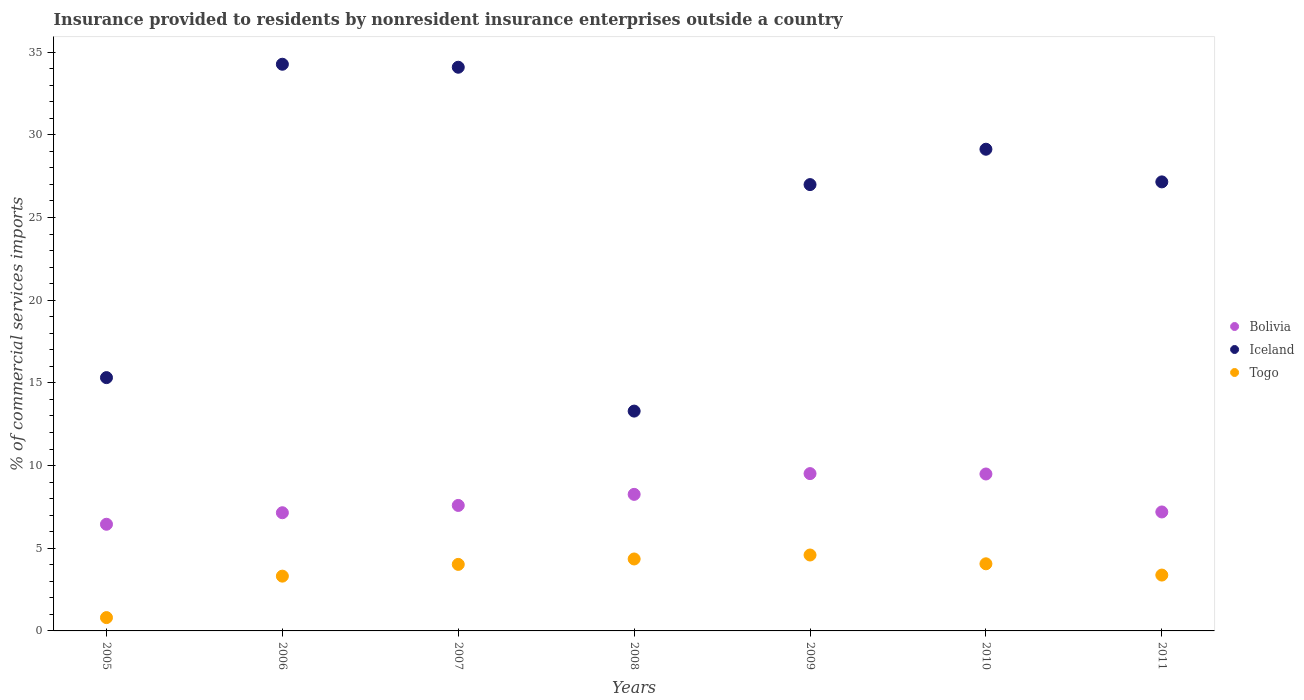How many different coloured dotlines are there?
Provide a succinct answer. 3. What is the Insurance provided to residents in Bolivia in 2010?
Your answer should be compact. 9.49. Across all years, what is the maximum Insurance provided to residents in Iceland?
Keep it short and to the point. 34.27. Across all years, what is the minimum Insurance provided to residents in Iceland?
Provide a short and direct response. 13.29. In which year was the Insurance provided to residents in Togo maximum?
Your answer should be compact. 2009. What is the total Insurance provided to residents in Iceland in the graph?
Your answer should be compact. 180.25. What is the difference between the Insurance provided to residents in Bolivia in 2005 and that in 2010?
Ensure brevity in your answer.  -3.04. What is the difference between the Insurance provided to residents in Bolivia in 2008 and the Insurance provided to residents in Togo in 2007?
Offer a very short reply. 4.23. What is the average Insurance provided to residents in Togo per year?
Your answer should be very brief. 3.5. In the year 2008, what is the difference between the Insurance provided to residents in Togo and Insurance provided to residents in Iceland?
Ensure brevity in your answer.  -8.94. In how many years, is the Insurance provided to residents in Bolivia greater than 10 %?
Give a very brief answer. 0. What is the ratio of the Insurance provided to residents in Bolivia in 2009 to that in 2011?
Your response must be concise. 1.32. Is the Insurance provided to residents in Togo in 2005 less than that in 2011?
Your answer should be compact. Yes. What is the difference between the highest and the second highest Insurance provided to residents in Iceland?
Provide a succinct answer. 0.18. What is the difference between the highest and the lowest Insurance provided to residents in Iceland?
Provide a short and direct response. 20.98. Is the Insurance provided to residents in Togo strictly less than the Insurance provided to residents in Iceland over the years?
Provide a short and direct response. Yes. How many dotlines are there?
Offer a terse response. 3. What is the difference between two consecutive major ticks on the Y-axis?
Your answer should be compact. 5. Does the graph contain any zero values?
Your answer should be compact. No. Does the graph contain grids?
Ensure brevity in your answer.  No. Where does the legend appear in the graph?
Provide a succinct answer. Center right. What is the title of the graph?
Your response must be concise. Insurance provided to residents by nonresident insurance enterprises outside a country. What is the label or title of the Y-axis?
Offer a very short reply. % of commercial services imports. What is the % of commercial services imports in Bolivia in 2005?
Ensure brevity in your answer.  6.45. What is the % of commercial services imports of Iceland in 2005?
Ensure brevity in your answer.  15.32. What is the % of commercial services imports in Togo in 2005?
Make the answer very short. 0.81. What is the % of commercial services imports in Bolivia in 2006?
Your answer should be compact. 7.15. What is the % of commercial services imports in Iceland in 2006?
Make the answer very short. 34.27. What is the % of commercial services imports in Togo in 2006?
Your response must be concise. 3.31. What is the % of commercial services imports in Bolivia in 2007?
Your response must be concise. 7.59. What is the % of commercial services imports of Iceland in 2007?
Offer a terse response. 34.09. What is the % of commercial services imports in Togo in 2007?
Your answer should be very brief. 4.02. What is the % of commercial services imports of Bolivia in 2008?
Give a very brief answer. 8.26. What is the % of commercial services imports of Iceland in 2008?
Make the answer very short. 13.29. What is the % of commercial services imports in Togo in 2008?
Offer a terse response. 4.35. What is the % of commercial services imports in Bolivia in 2009?
Your answer should be compact. 9.51. What is the % of commercial services imports of Iceland in 2009?
Offer a very short reply. 26.99. What is the % of commercial services imports in Togo in 2009?
Offer a terse response. 4.59. What is the % of commercial services imports in Bolivia in 2010?
Ensure brevity in your answer.  9.49. What is the % of commercial services imports of Iceland in 2010?
Provide a short and direct response. 29.13. What is the % of commercial services imports in Togo in 2010?
Your response must be concise. 4.06. What is the % of commercial services imports of Bolivia in 2011?
Keep it short and to the point. 7.19. What is the % of commercial services imports of Iceland in 2011?
Offer a very short reply. 27.16. What is the % of commercial services imports of Togo in 2011?
Offer a very short reply. 3.38. Across all years, what is the maximum % of commercial services imports of Bolivia?
Offer a very short reply. 9.51. Across all years, what is the maximum % of commercial services imports of Iceland?
Give a very brief answer. 34.27. Across all years, what is the maximum % of commercial services imports in Togo?
Provide a short and direct response. 4.59. Across all years, what is the minimum % of commercial services imports of Bolivia?
Make the answer very short. 6.45. Across all years, what is the minimum % of commercial services imports of Iceland?
Offer a terse response. 13.29. Across all years, what is the minimum % of commercial services imports in Togo?
Give a very brief answer. 0.81. What is the total % of commercial services imports of Bolivia in the graph?
Your answer should be compact. 55.64. What is the total % of commercial services imports of Iceland in the graph?
Offer a terse response. 180.25. What is the total % of commercial services imports of Togo in the graph?
Provide a succinct answer. 24.52. What is the difference between the % of commercial services imports in Bolivia in 2005 and that in 2006?
Your answer should be compact. -0.7. What is the difference between the % of commercial services imports of Iceland in 2005 and that in 2006?
Offer a terse response. -18.95. What is the difference between the % of commercial services imports in Togo in 2005 and that in 2006?
Give a very brief answer. -2.51. What is the difference between the % of commercial services imports in Bolivia in 2005 and that in 2007?
Ensure brevity in your answer.  -1.14. What is the difference between the % of commercial services imports in Iceland in 2005 and that in 2007?
Provide a succinct answer. -18.77. What is the difference between the % of commercial services imports in Togo in 2005 and that in 2007?
Provide a succinct answer. -3.22. What is the difference between the % of commercial services imports in Bolivia in 2005 and that in 2008?
Offer a terse response. -1.81. What is the difference between the % of commercial services imports of Iceland in 2005 and that in 2008?
Offer a very short reply. 2.03. What is the difference between the % of commercial services imports of Togo in 2005 and that in 2008?
Your answer should be compact. -3.55. What is the difference between the % of commercial services imports of Bolivia in 2005 and that in 2009?
Keep it short and to the point. -3.06. What is the difference between the % of commercial services imports of Iceland in 2005 and that in 2009?
Ensure brevity in your answer.  -11.67. What is the difference between the % of commercial services imports in Togo in 2005 and that in 2009?
Your response must be concise. -3.79. What is the difference between the % of commercial services imports in Bolivia in 2005 and that in 2010?
Give a very brief answer. -3.04. What is the difference between the % of commercial services imports in Iceland in 2005 and that in 2010?
Provide a succinct answer. -13.81. What is the difference between the % of commercial services imports of Togo in 2005 and that in 2010?
Your answer should be compact. -3.25. What is the difference between the % of commercial services imports in Bolivia in 2005 and that in 2011?
Provide a succinct answer. -0.74. What is the difference between the % of commercial services imports of Iceland in 2005 and that in 2011?
Give a very brief answer. -11.84. What is the difference between the % of commercial services imports of Togo in 2005 and that in 2011?
Make the answer very short. -2.57. What is the difference between the % of commercial services imports of Bolivia in 2006 and that in 2007?
Give a very brief answer. -0.44. What is the difference between the % of commercial services imports of Iceland in 2006 and that in 2007?
Offer a terse response. 0.18. What is the difference between the % of commercial services imports in Togo in 2006 and that in 2007?
Offer a very short reply. -0.71. What is the difference between the % of commercial services imports in Bolivia in 2006 and that in 2008?
Provide a short and direct response. -1.11. What is the difference between the % of commercial services imports in Iceland in 2006 and that in 2008?
Your answer should be compact. 20.98. What is the difference between the % of commercial services imports of Togo in 2006 and that in 2008?
Keep it short and to the point. -1.04. What is the difference between the % of commercial services imports in Bolivia in 2006 and that in 2009?
Keep it short and to the point. -2.37. What is the difference between the % of commercial services imports of Iceland in 2006 and that in 2009?
Provide a succinct answer. 7.28. What is the difference between the % of commercial services imports of Togo in 2006 and that in 2009?
Your answer should be very brief. -1.28. What is the difference between the % of commercial services imports in Bolivia in 2006 and that in 2010?
Provide a short and direct response. -2.34. What is the difference between the % of commercial services imports of Iceland in 2006 and that in 2010?
Give a very brief answer. 5.14. What is the difference between the % of commercial services imports in Togo in 2006 and that in 2010?
Your answer should be very brief. -0.75. What is the difference between the % of commercial services imports of Bolivia in 2006 and that in 2011?
Make the answer very short. -0.05. What is the difference between the % of commercial services imports of Iceland in 2006 and that in 2011?
Provide a succinct answer. 7.11. What is the difference between the % of commercial services imports of Togo in 2006 and that in 2011?
Provide a short and direct response. -0.06. What is the difference between the % of commercial services imports in Bolivia in 2007 and that in 2008?
Your answer should be very brief. -0.67. What is the difference between the % of commercial services imports of Iceland in 2007 and that in 2008?
Your response must be concise. 20.8. What is the difference between the % of commercial services imports of Togo in 2007 and that in 2008?
Provide a short and direct response. -0.33. What is the difference between the % of commercial services imports of Bolivia in 2007 and that in 2009?
Keep it short and to the point. -1.92. What is the difference between the % of commercial services imports of Iceland in 2007 and that in 2009?
Make the answer very short. 7.1. What is the difference between the % of commercial services imports of Togo in 2007 and that in 2009?
Offer a terse response. -0.57. What is the difference between the % of commercial services imports in Bolivia in 2007 and that in 2010?
Offer a terse response. -1.9. What is the difference between the % of commercial services imports of Iceland in 2007 and that in 2010?
Make the answer very short. 4.96. What is the difference between the % of commercial services imports of Togo in 2007 and that in 2010?
Offer a very short reply. -0.04. What is the difference between the % of commercial services imports of Bolivia in 2007 and that in 2011?
Provide a short and direct response. 0.39. What is the difference between the % of commercial services imports in Iceland in 2007 and that in 2011?
Give a very brief answer. 6.93. What is the difference between the % of commercial services imports of Togo in 2007 and that in 2011?
Your answer should be compact. 0.65. What is the difference between the % of commercial services imports in Bolivia in 2008 and that in 2009?
Offer a terse response. -1.26. What is the difference between the % of commercial services imports of Iceland in 2008 and that in 2009?
Ensure brevity in your answer.  -13.7. What is the difference between the % of commercial services imports of Togo in 2008 and that in 2009?
Make the answer very short. -0.24. What is the difference between the % of commercial services imports in Bolivia in 2008 and that in 2010?
Provide a succinct answer. -1.23. What is the difference between the % of commercial services imports in Iceland in 2008 and that in 2010?
Give a very brief answer. -15.84. What is the difference between the % of commercial services imports in Togo in 2008 and that in 2010?
Your response must be concise. 0.29. What is the difference between the % of commercial services imports in Bolivia in 2008 and that in 2011?
Your response must be concise. 1.06. What is the difference between the % of commercial services imports of Iceland in 2008 and that in 2011?
Make the answer very short. -13.86. What is the difference between the % of commercial services imports in Togo in 2008 and that in 2011?
Provide a succinct answer. 0.97. What is the difference between the % of commercial services imports in Bolivia in 2009 and that in 2010?
Keep it short and to the point. 0.02. What is the difference between the % of commercial services imports in Iceland in 2009 and that in 2010?
Give a very brief answer. -2.14. What is the difference between the % of commercial services imports in Togo in 2009 and that in 2010?
Provide a short and direct response. 0.53. What is the difference between the % of commercial services imports in Bolivia in 2009 and that in 2011?
Give a very brief answer. 2.32. What is the difference between the % of commercial services imports in Iceland in 2009 and that in 2011?
Keep it short and to the point. -0.16. What is the difference between the % of commercial services imports of Togo in 2009 and that in 2011?
Your response must be concise. 1.21. What is the difference between the % of commercial services imports of Bolivia in 2010 and that in 2011?
Your answer should be compact. 2.3. What is the difference between the % of commercial services imports in Iceland in 2010 and that in 2011?
Ensure brevity in your answer.  1.98. What is the difference between the % of commercial services imports in Togo in 2010 and that in 2011?
Provide a succinct answer. 0.68. What is the difference between the % of commercial services imports in Bolivia in 2005 and the % of commercial services imports in Iceland in 2006?
Offer a terse response. -27.82. What is the difference between the % of commercial services imports in Bolivia in 2005 and the % of commercial services imports in Togo in 2006?
Give a very brief answer. 3.14. What is the difference between the % of commercial services imports in Iceland in 2005 and the % of commercial services imports in Togo in 2006?
Provide a succinct answer. 12.01. What is the difference between the % of commercial services imports in Bolivia in 2005 and the % of commercial services imports in Iceland in 2007?
Your answer should be compact. -27.64. What is the difference between the % of commercial services imports of Bolivia in 2005 and the % of commercial services imports of Togo in 2007?
Ensure brevity in your answer.  2.43. What is the difference between the % of commercial services imports in Iceland in 2005 and the % of commercial services imports in Togo in 2007?
Give a very brief answer. 11.3. What is the difference between the % of commercial services imports of Bolivia in 2005 and the % of commercial services imports of Iceland in 2008?
Your response must be concise. -6.84. What is the difference between the % of commercial services imports of Bolivia in 2005 and the % of commercial services imports of Togo in 2008?
Make the answer very short. 2.1. What is the difference between the % of commercial services imports of Iceland in 2005 and the % of commercial services imports of Togo in 2008?
Your answer should be compact. 10.97. What is the difference between the % of commercial services imports in Bolivia in 2005 and the % of commercial services imports in Iceland in 2009?
Provide a succinct answer. -20.54. What is the difference between the % of commercial services imports of Bolivia in 2005 and the % of commercial services imports of Togo in 2009?
Ensure brevity in your answer.  1.86. What is the difference between the % of commercial services imports of Iceland in 2005 and the % of commercial services imports of Togo in 2009?
Make the answer very short. 10.73. What is the difference between the % of commercial services imports of Bolivia in 2005 and the % of commercial services imports of Iceland in 2010?
Your answer should be very brief. -22.68. What is the difference between the % of commercial services imports of Bolivia in 2005 and the % of commercial services imports of Togo in 2010?
Your response must be concise. 2.39. What is the difference between the % of commercial services imports in Iceland in 2005 and the % of commercial services imports in Togo in 2010?
Your answer should be compact. 11.26. What is the difference between the % of commercial services imports of Bolivia in 2005 and the % of commercial services imports of Iceland in 2011?
Offer a terse response. -20.7. What is the difference between the % of commercial services imports of Bolivia in 2005 and the % of commercial services imports of Togo in 2011?
Provide a short and direct response. 3.07. What is the difference between the % of commercial services imports of Iceland in 2005 and the % of commercial services imports of Togo in 2011?
Provide a short and direct response. 11.94. What is the difference between the % of commercial services imports of Bolivia in 2006 and the % of commercial services imports of Iceland in 2007?
Make the answer very short. -26.94. What is the difference between the % of commercial services imports of Bolivia in 2006 and the % of commercial services imports of Togo in 2007?
Your answer should be very brief. 3.12. What is the difference between the % of commercial services imports in Iceland in 2006 and the % of commercial services imports in Togo in 2007?
Make the answer very short. 30.25. What is the difference between the % of commercial services imports in Bolivia in 2006 and the % of commercial services imports in Iceland in 2008?
Your response must be concise. -6.15. What is the difference between the % of commercial services imports in Bolivia in 2006 and the % of commercial services imports in Togo in 2008?
Keep it short and to the point. 2.8. What is the difference between the % of commercial services imports in Iceland in 2006 and the % of commercial services imports in Togo in 2008?
Your answer should be very brief. 29.92. What is the difference between the % of commercial services imports of Bolivia in 2006 and the % of commercial services imports of Iceland in 2009?
Provide a succinct answer. -19.84. What is the difference between the % of commercial services imports in Bolivia in 2006 and the % of commercial services imports in Togo in 2009?
Make the answer very short. 2.56. What is the difference between the % of commercial services imports of Iceland in 2006 and the % of commercial services imports of Togo in 2009?
Your response must be concise. 29.68. What is the difference between the % of commercial services imports of Bolivia in 2006 and the % of commercial services imports of Iceland in 2010?
Your answer should be very brief. -21.98. What is the difference between the % of commercial services imports of Bolivia in 2006 and the % of commercial services imports of Togo in 2010?
Provide a succinct answer. 3.09. What is the difference between the % of commercial services imports in Iceland in 2006 and the % of commercial services imports in Togo in 2010?
Your answer should be compact. 30.21. What is the difference between the % of commercial services imports in Bolivia in 2006 and the % of commercial services imports in Iceland in 2011?
Offer a terse response. -20.01. What is the difference between the % of commercial services imports in Bolivia in 2006 and the % of commercial services imports in Togo in 2011?
Ensure brevity in your answer.  3.77. What is the difference between the % of commercial services imports in Iceland in 2006 and the % of commercial services imports in Togo in 2011?
Give a very brief answer. 30.89. What is the difference between the % of commercial services imports in Bolivia in 2007 and the % of commercial services imports in Iceland in 2008?
Ensure brevity in your answer.  -5.7. What is the difference between the % of commercial services imports of Bolivia in 2007 and the % of commercial services imports of Togo in 2008?
Provide a short and direct response. 3.24. What is the difference between the % of commercial services imports of Iceland in 2007 and the % of commercial services imports of Togo in 2008?
Provide a succinct answer. 29.74. What is the difference between the % of commercial services imports in Bolivia in 2007 and the % of commercial services imports in Iceland in 2009?
Ensure brevity in your answer.  -19.4. What is the difference between the % of commercial services imports in Bolivia in 2007 and the % of commercial services imports in Togo in 2009?
Keep it short and to the point. 3. What is the difference between the % of commercial services imports in Iceland in 2007 and the % of commercial services imports in Togo in 2009?
Ensure brevity in your answer.  29.5. What is the difference between the % of commercial services imports of Bolivia in 2007 and the % of commercial services imports of Iceland in 2010?
Your answer should be compact. -21.54. What is the difference between the % of commercial services imports in Bolivia in 2007 and the % of commercial services imports in Togo in 2010?
Provide a short and direct response. 3.53. What is the difference between the % of commercial services imports of Iceland in 2007 and the % of commercial services imports of Togo in 2010?
Offer a terse response. 30.03. What is the difference between the % of commercial services imports of Bolivia in 2007 and the % of commercial services imports of Iceland in 2011?
Provide a short and direct response. -19.57. What is the difference between the % of commercial services imports in Bolivia in 2007 and the % of commercial services imports in Togo in 2011?
Your answer should be compact. 4.21. What is the difference between the % of commercial services imports in Iceland in 2007 and the % of commercial services imports in Togo in 2011?
Keep it short and to the point. 30.71. What is the difference between the % of commercial services imports of Bolivia in 2008 and the % of commercial services imports of Iceland in 2009?
Your answer should be compact. -18.73. What is the difference between the % of commercial services imports in Bolivia in 2008 and the % of commercial services imports in Togo in 2009?
Make the answer very short. 3.67. What is the difference between the % of commercial services imports in Iceland in 2008 and the % of commercial services imports in Togo in 2009?
Offer a very short reply. 8.7. What is the difference between the % of commercial services imports in Bolivia in 2008 and the % of commercial services imports in Iceland in 2010?
Offer a terse response. -20.87. What is the difference between the % of commercial services imports in Bolivia in 2008 and the % of commercial services imports in Togo in 2010?
Provide a short and direct response. 4.2. What is the difference between the % of commercial services imports of Iceland in 2008 and the % of commercial services imports of Togo in 2010?
Your answer should be compact. 9.23. What is the difference between the % of commercial services imports of Bolivia in 2008 and the % of commercial services imports of Iceland in 2011?
Give a very brief answer. -18.9. What is the difference between the % of commercial services imports of Bolivia in 2008 and the % of commercial services imports of Togo in 2011?
Offer a very short reply. 4.88. What is the difference between the % of commercial services imports in Iceland in 2008 and the % of commercial services imports in Togo in 2011?
Provide a succinct answer. 9.92. What is the difference between the % of commercial services imports of Bolivia in 2009 and the % of commercial services imports of Iceland in 2010?
Make the answer very short. -19.62. What is the difference between the % of commercial services imports in Bolivia in 2009 and the % of commercial services imports in Togo in 2010?
Provide a short and direct response. 5.45. What is the difference between the % of commercial services imports in Iceland in 2009 and the % of commercial services imports in Togo in 2010?
Provide a succinct answer. 22.93. What is the difference between the % of commercial services imports in Bolivia in 2009 and the % of commercial services imports in Iceland in 2011?
Ensure brevity in your answer.  -17.64. What is the difference between the % of commercial services imports of Bolivia in 2009 and the % of commercial services imports of Togo in 2011?
Ensure brevity in your answer.  6.14. What is the difference between the % of commercial services imports in Iceland in 2009 and the % of commercial services imports in Togo in 2011?
Your answer should be very brief. 23.61. What is the difference between the % of commercial services imports of Bolivia in 2010 and the % of commercial services imports of Iceland in 2011?
Your answer should be very brief. -17.66. What is the difference between the % of commercial services imports of Bolivia in 2010 and the % of commercial services imports of Togo in 2011?
Offer a very short reply. 6.11. What is the difference between the % of commercial services imports in Iceland in 2010 and the % of commercial services imports in Togo in 2011?
Your answer should be compact. 25.75. What is the average % of commercial services imports in Bolivia per year?
Offer a terse response. 7.95. What is the average % of commercial services imports in Iceland per year?
Your answer should be very brief. 25.75. What is the average % of commercial services imports in Togo per year?
Give a very brief answer. 3.5. In the year 2005, what is the difference between the % of commercial services imports of Bolivia and % of commercial services imports of Iceland?
Your response must be concise. -8.87. In the year 2005, what is the difference between the % of commercial services imports in Bolivia and % of commercial services imports in Togo?
Make the answer very short. 5.65. In the year 2005, what is the difference between the % of commercial services imports of Iceland and % of commercial services imports of Togo?
Provide a succinct answer. 14.51. In the year 2006, what is the difference between the % of commercial services imports in Bolivia and % of commercial services imports in Iceland?
Provide a short and direct response. -27.12. In the year 2006, what is the difference between the % of commercial services imports of Bolivia and % of commercial services imports of Togo?
Keep it short and to the point. 3.83. In the year 2006, what is the difference between the % of commercial services imports of Iceland and % of commercial services imports of Togo?
Offer a very short reply. 30.96. In the year 2007, what is the difference between the % of commercial services imports in Bolivia and % of commercial services imports in Iceland?
Your answer should be compact. -26.5. In the year 2007, what is the difference between the % of commercial services imports of Bolivia and % of commercial services imports of Togo?
Offer a very short reply. 3.57. In the year 2007, what is the difference between the % of commercial services imports in Iceland and % of commercial services imports in Togo?
Offer a very short reply. 30.07. In the year 2008, what is the difference between the % of commercial services imports in Bolivia and % of commercial services imports in Iceland?
Your answer should be compact. -5.04. In the year 2008, what is the difference between the % of commercial services imports of Bolivia and % of commercial services imports of Togo?
Offer a very short reply. 3.91. In the year 2008, what is the difference between the % of commercial services imports in Iceland and % of commercial services imports in Togo?
Provide a succinct answer. 8.94. In the year 2009, what is the difference between the % of commercial services imports of Bolivia and % of commercial services imports of Iceland?
Offer a terse response. -17.48. In the year 2009, what is the difference between the % of commercial services imports of Bolivia and % of commercial services imports of Togo?
Your answer should be compact. 4.92. In the year 2009, what is the difference between the % of commercial services imports of Iceland and % of commercial services imports of Togo?
Offer a very short reply. 22.4. In the year 2010, what is the difference between the % of commercial services imports in Bolivia and % of commercial services imports in Iceland?
Offer a very short reply. -19.64. In the year 2010, what is the difference between the % of commercial services imports of Bolivia and % of commercial services imports of Togo?
Keep it short and to the point. 5.43. In the year 2010, what is the difference between the % of commercial services imports of Iceland and % of commercial services imports of Togo?
Make the answer very short. 25.07. In the year 2011, what is the difference between the % of commercial services imports in Bolivia and % of commercial services imports in Iceland?
Your response must be concise. -19.96. In the year 2011, what is the difference between the % of commercial services imports of Bolivia and % of commercial services imports of Togo?
Provide a succinct answer. 3.82. In the year 2011, what is the difference between the % of commercial services imports of Iceland and % of commercial services imports of Togo?
Your response must be concise. 23.78. What is the ratio of the % of commercial services imports of Bolivia in 2005 to that in 2006?
Offer a very short reply. 0.9. What is the ratio of the % of commercial services imports in Iceland in 2005 to that in 2006?
Ensure brevity in your answer.  0.45. What is the ratio of the % of commercial services imports in Togo in 2005 to that in 2006?
Offer a very short reply. 0.24. What is the ratio of the % of commercial services imports of Bolivia in 2005 to that in 2007?
Your response must be concise. 0.85. What is the ratio of the % of commercial services imports in Iceland in 2005 to that in 2007?
Offer a terse response. 0.45. What is the ratio of the % of commercial services imports in Togo in 2005 to that in 2007?
Offer a terse response. 0.2. What is the ratio of the % of commercial services imports in Bolivia in 2005 to that in 2008?
Your answer should be very brief. 0.78. What is the ratio of the % of commercial services imports in Iceland in 2005 to that in 2008?
Ensure brevity in your answer.  1.15. What is the ratio of the % of commercial services imports in Togo in 2005 to that in 2008?
Provide a short and direct response. 0.19. What is the ratio of the % of commercial services imports in Bolivia in 2005 to that in 2009?
Provide a short and direct response. 0.68. What is the ratio of the % of commercial services imports of Iceland in 2005 to that in 2009?
Make the answer very short. 0.57. What is the ratio of the % of commercial services imports of Togo in 2005 to that in 2009?
Give a very brief answer. 0.18. What is the ratio of the % of commercial services imports of Bolivia in 2005 to that in 2010?
Your answer should be compact. 0.68. What is the ratio of the % of commercial services imports of Iceland in 2005 to that in 2010?
Provide a succinct answer. 0.53. What is the ratio of the % of commercial services imports of Togo in 2005 to that in 2010?
Offer a terse response. 0.2. What is the ratio of the % of commercial services imports of Bolivia in 2005 to that in 2011?
Provide a short and direct response. 0.9. What is the ratio of the % of commercial services imports in Iceland in 2005 to that in 2011?
Provide a succinct answer. 0.56. What is the ratio of the % of commercial services imports in Togo in 2005 to that in 2011?
Ensure brevity in your answer.  0.24. What is the ratio of the % of commercial services imports in Bolivia in 2006 to that in 2007?
Make the answer very short. 0.94. What is the ratio of the % of commercial services imports of Iceland in 2006 to that in 2007?
Provide a short and direct response. 1.01. What is the ratio of the % of commercial services imports in Togo in 2006 to that in 2007?
Your answer should be compact. 0.82. What is the ratio of the % of commercial services imports of Bolivia in 2006 to that in 2008?
Your response must be concise. 0.87. What is the ratio of the % of commercial services imports in Iceland in 2006 to that in 2008?
Give a very brief answer. 2.58. What is the ratio of the % of commercial services imports of Togo in 2006 to that in 2008?
Your answer should be very brief. 0.76. What is the ratio of the % of commercial services imports in Bolivia in 2006 to that in 2009?
Provide a succinct answer. 0.75. What is the ratio of the % of commercial services imports in Iceland in 2006 to that in 2009?
Your response must be concise. 1.27. What is the ratio of the % of commercial services imports of Togo in 2006 to that in 2009?
Your response must be concise. 0.72. What is the ratio of the % of commercial services imports in Bolivia in 2006 to that in 2010?
Ensure brevity in your answer.  0.75. What is the ratio of the % of commercial services imports of Iceland in 2006 to that in 2010?
Your answer should be compact. 1.18. What is the ratio of the % of commercial services imports in Togo in 2006 to that in 2010?
Make the answer very short. 0.82. What is the ratio of the % of commercial services imports in Iceland in 2006 to that in 2011?
Give a very brief answer. 1.26. What is the ratio of the % of commercial services imports in Togo in 2006 to that in 2011?
Provide a short and direct response. 0.98. What is the ratio of the % of commercial services imports of Bolivia in 2007 to that in 2008?
Ensure brevity in your answer.  0.92. What is the ratio of the % of commercial services imports of Iceland in 2007 to that in 2008?
Give a very brief answer. 2.56. What is the ratio of the % of commercial services imports of Togo in 2007 to that in 2008?
Your answer should be very brief. 0.92. What is the ratio of the % of commercial services imports of Bolivia in 2007 to that in 2009?
Provide a succinct answer. 0.8. What is the ratio of the % of commercial services imports in Iceland in 2007 to that in 2009?
Provide a short and direct response. 1.26. What is the ratio of the % of commercial services imports of Togo in 2007 to that in 2009?
Your response must be concise. 0.88. What is the ratio of the % of commercial services imports in Bolivia in 2007 to that in 2010?
Offer a terse response. 0.8. What is the ratio of the % of commercial services imports in Iceland in 2007 to that in 2010?
Make the answer very short. 1.17. What is the ratio of the % of commercial services imports of Bolivia in 2007 to that in 2011?
Your response must be concise. 1.05. What is the ratio of the % of commercial services imports of Iceland in 2007 to that in 2011?
Keep it short and to the point. 1.26. What is the ratio of the % of commercial services imports of Togo in 2007 to that in 2011?
Your answer should be very brief. 1.19. What is the ratio of the % of commercial services imports in Bolivia in 2008 to that in 2009?
Your answer should be very brief. 0.87. What is the ratio of the % of commercial services imports of Iceland in 2008 to that in 2009?
Keep it short and to the point. 0.49. What is the ratio of the % of commercial services imports of Togo in 2008 to that in 2009?
Keep it short and to the point. 0.95. What is the ratio of the % of commercial services imports in Bolivia in 2008 to that in 2010?
Give a very brief answer. 0.87. What is the ratio of the % of commercial services imports in Iceland in 2008 to that in 2010?
Offer a terse response. 0.46. What is the ratio of the % of commercial services imports in Togo in 2008 to that in 2010?
Keep it short and to the point. 1.07. What is the ratio of the % of commercial services imports in Bolivia in 2008 to that in 2011?
Your answer should be compact. 1.15. What is the ratio of the % of commercial services imports in Iceland in 2008 to that in 2011?
Ensure brevity in your answer.  0.49. What is the ratio of the % of commercial services imports of Togo in 2008 to that in 2011?
Offer a terse response. 1.29. What is the ratio of the % of commercial services imports in Iceland in 2009 to that in 2010?
Offer a terse response. 0.93. What is the ratio of the % of commercial services imports of Togo in 2009 to that in 2010?
Your response must be concise. 1.13. What is the ratio of the % of commercial services imports in Bolivia in 2009 to that in 2011?
Offer a terse response. 1.32. What is the ratio of the % of commercial services imports of Iceland in 2009 to that in 2011?
Provide a succinct answer. 0.99. What is the ratio of the % of commercial services imports in Togo in 2009 to that in 2011?
Provide a short and direct response. 1.36. What is the ratio of the % of commercial services imports in Bolivia in 2010 to that in 2011?
Your answer should be very brief. 1.32. What is the ratio of the % of commercial services imports of Iceland in 2010 to that in 2011?
Provide a succinct answer. 1.07. What is the ratio of the % of commercial services imports of Togo in 2010 to that in 2011?
Give a very brief answer. 1.2. What is the difference between the highest and the second highest % of commercial services imports of Bolivia?
Offer a terse response. 0.02. What is the difference between the highest and the second highest % of commercial services imports of Iceland?
Offer a very short reply. 0.18. What is the difference between the highest and the second highest % of commercial services imports of Togo?
Your response must be concise. 0.24. What is the difference between the highest and the lowest % of commercial services imports in Bolivia?
Your answer should be compact. 3.06. What is the difference between the highest and the lowest % of commercial services imports in Iceland?
Make the answer very short. 20.98. What is the difference between the highest and the lowest % of commercial services imports in Togo?
Offer a terse response. 3.79. 